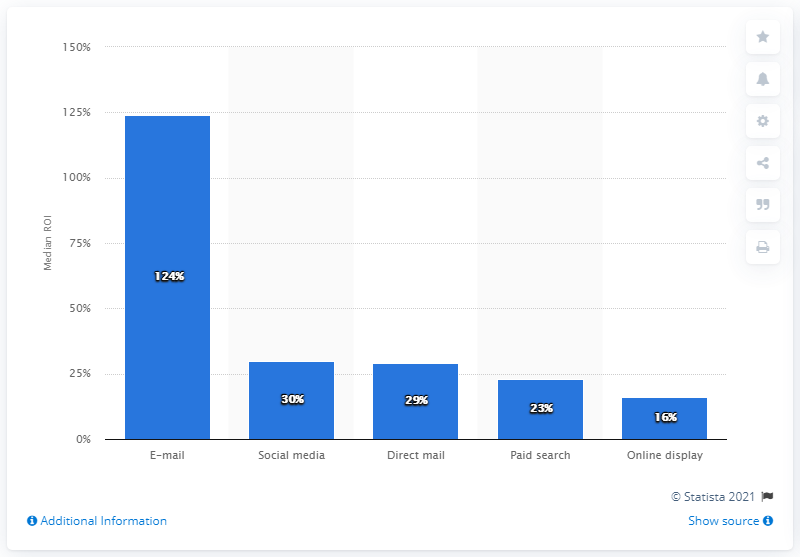Specify some key components in this picture. The median return on investment (ROI) of social media marketing was 30%. 